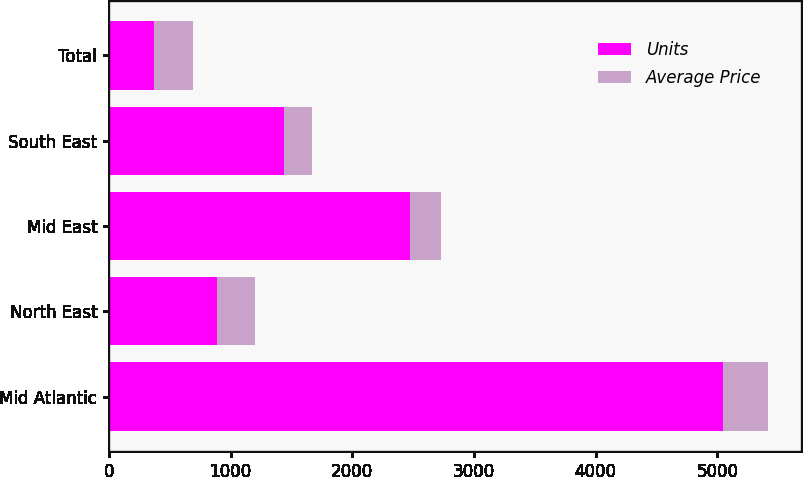Convert chart to OTSL. <chart><loc_0><loc_0><loc_500><loc_500><stacked_bar_chart><ecel><fcel>Mid Atlantic<fcel>North East<fcel>Mid East<fcel>South East<fcel>Total<nl><fcel>Units<fcel>5047<fcel>889<fcel>2472<fcel>1435<fcel>372.1<nl><fcel>Average Price<fcel>372.1<fcel>313.5<fcel>255<fcel>232.8<fcel>317.1<nl></chart> 